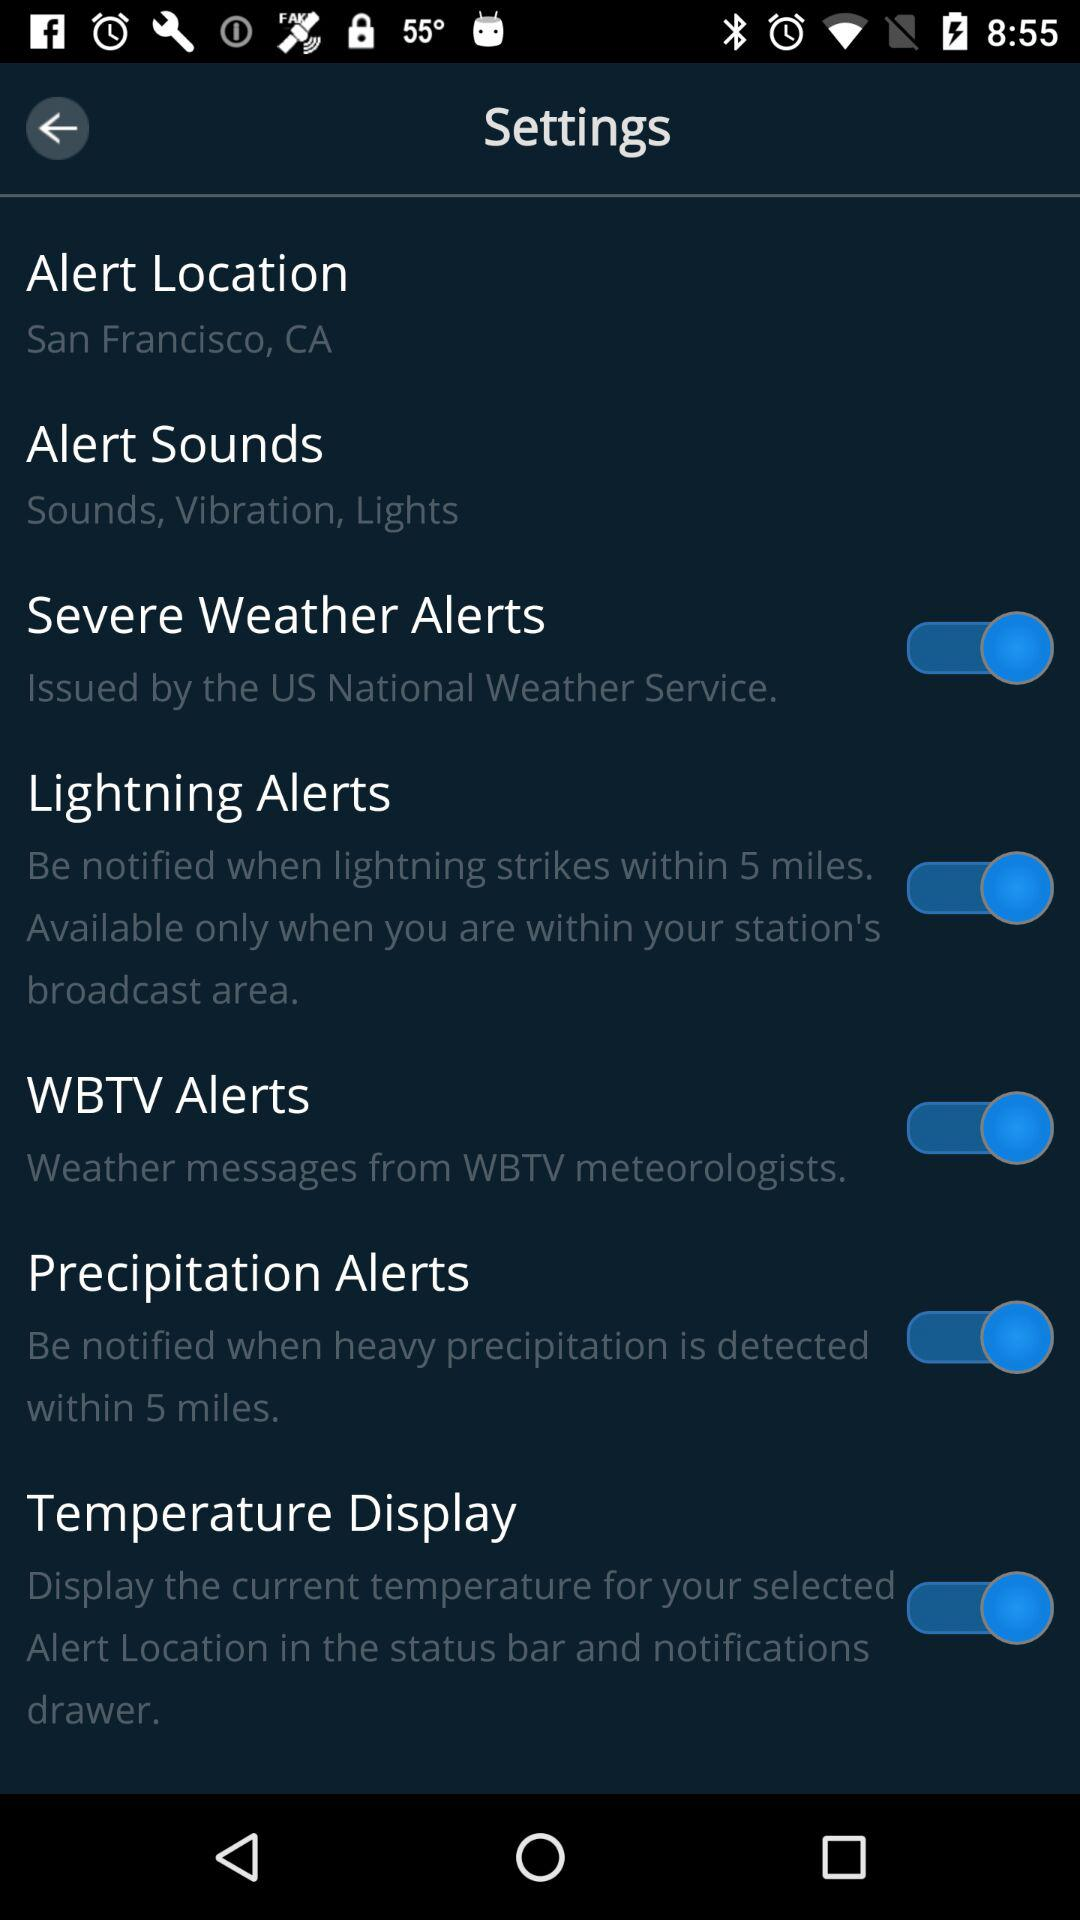What is the "Alert Location"? The "Alert Location" is San Francisco, CA. 